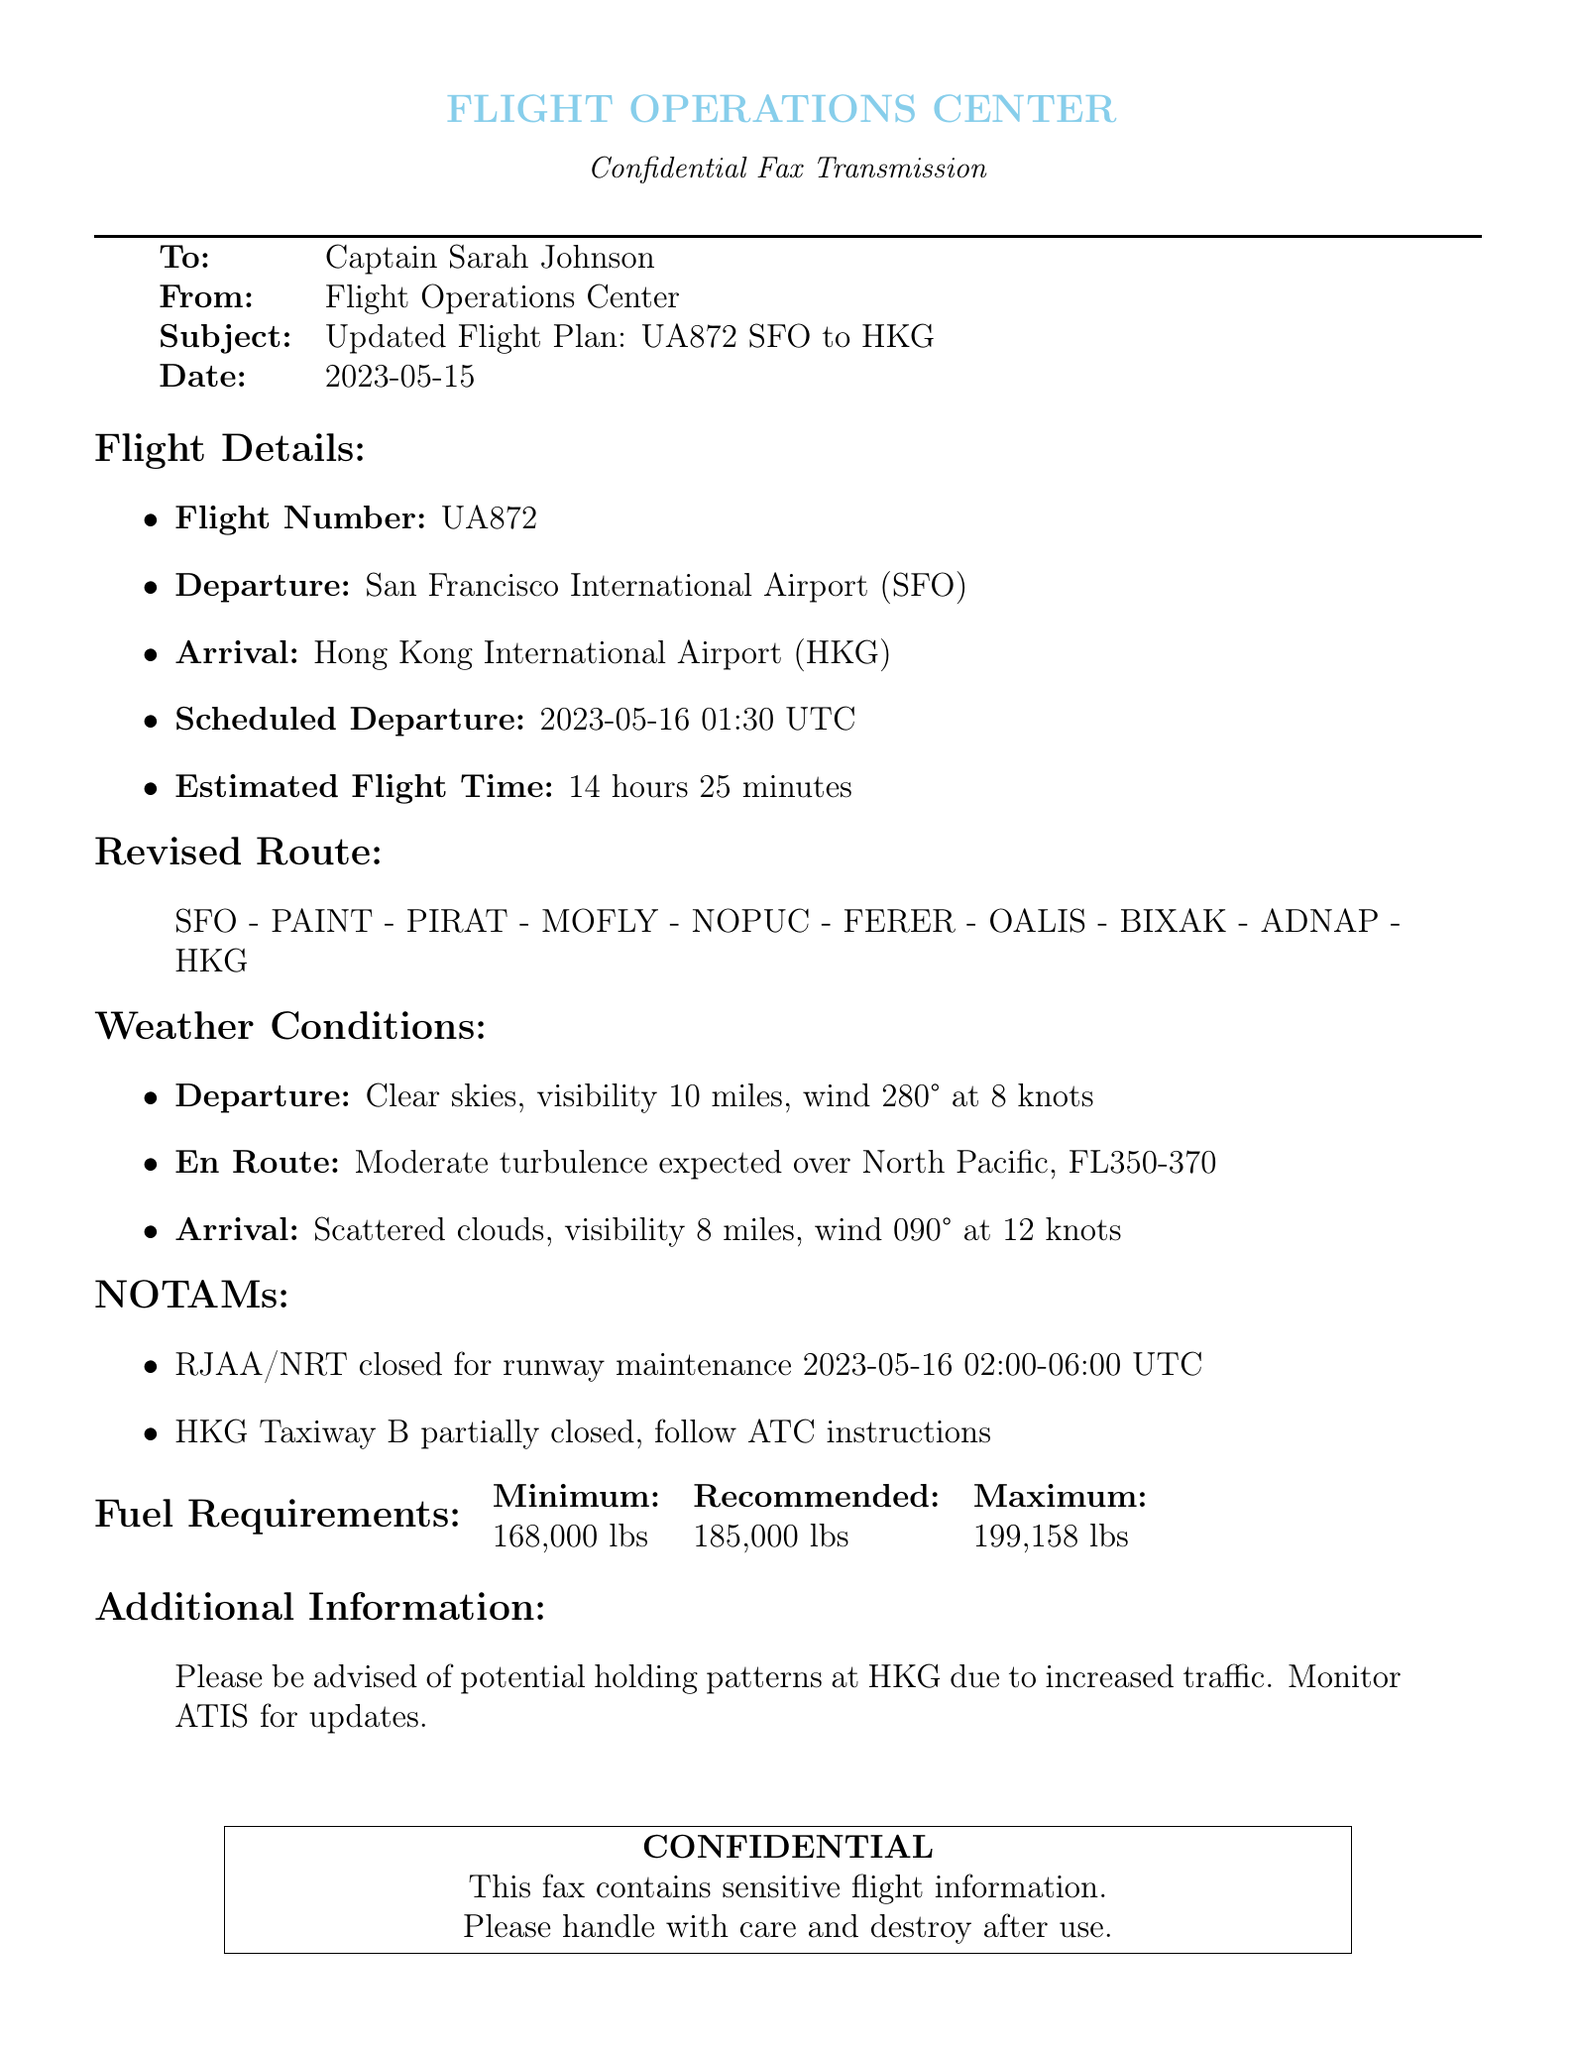what is the flight number? The flight number is listed in the flight details section of the document as UA872.
Answer: UA872 what is the scheduled departure time? The scheduled departure time is located in the flight details section, which states 2023-05-16 01:30 UTC.
Answer: 2023-05-16 01:30 UTC how long is the estimated flight time? The estimated flight time is specified in the flight details section; it states 14 hours 25 minutes.
Answer: 14 hours 25 minutes what is the weather condition for departure? The weather condition for departure is described in the weather conditions section and states "Clear skies, visibility 10 miles, wind 280° at 8 knots."
Answer: Clear skies, visibility 10 miles, wind 280° at 8 knots what will be the wind conditions upon arrival? The wind conditions upon arrival are indicated in the weather conditions section, which states "wind 090° at 12 knots."
Answer: wind 090° at 12 knots what is the minimum fuel requirement? The minimum fuel requirement is listed in the fuel requirements table that indicates 168,000 lbs.
Answer: 168,000 lbs what type of maintenance affects RJAA/NRT? The document states that RJAA/NRT is closed for "runway maintenance."
Answer: runway maintenance what should be monitored for potential changes? The additional information section advises to "Monitor ATIS for updates."
Answer: Monitor ATIS for updates what type of document is this? The document is identified as a "Confidential Fax Transmission" at the top.
Answer: Confidential Fax Transmission 